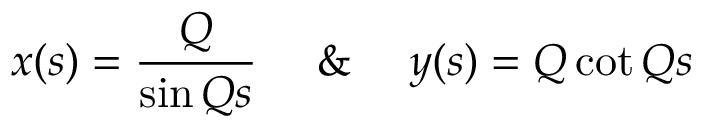<formula> <loc_0><loc_0><loc_500><loc_500>x ( s ) = \frac { Q } { \sin Q s } \quad \& \quad y ( s ) = Q \cot Q s</formula> 